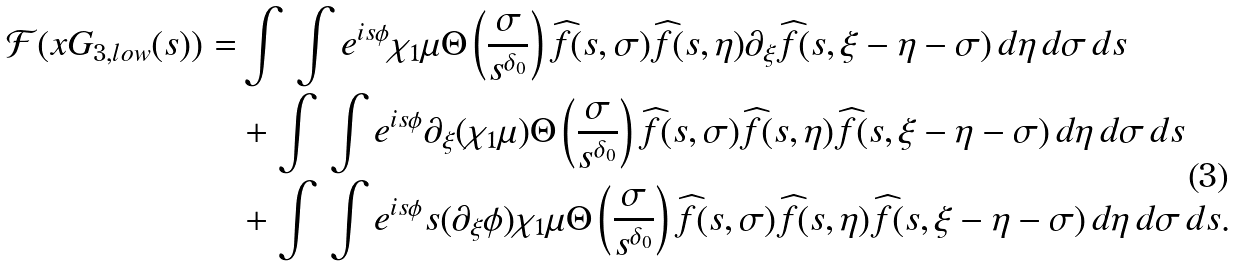Convert formula to latex. <formula><loc_0><loc_0><loc_500><loc_500>\mathcal { F } ( x G _ { 3 , l o w } ( s ) ) = & \int \, \int e ^ { i s \phi } \chi _ { 1 } \mu \Theta \left ( \frac { \sigma } { s ^ { \delta _ { 0 } } } \right ) \widehat { f } ( s , \sigma ) \widehat { f } ( s , \eta ) \partial _ { \xi } \widehat { f } ( s , \xi - \eta - \sigma ) \, d \eta \, d \sigma \, d s \\ & + \int \, \int e ^ { i s \phi } \partial _ { \xi } ( \chi _ { 1 } \mu ) \Theta \left ( \frac { \sigma } { s ^ { \delta _ { 0 } } } \right ) \widehat { f } ( s , \sigma ) \widehat { f } ( s , \eta ) \widehat { f } ( s , \xi - \eta - \sigma ) \, d \eta \, d \sigma \, d s \\ & + \int \, \int e ^ { i s \phi } s ( \partial _ { \xi } \phi ) \chi _ { 1 } \mu \Theta \left ( \frac { \sigma } { s ^ { \delta _ { 0 } } } \right ) \widehat { f } ( s , \sigma ) \widehat { f } ( s , \eta ) \widehat { f } ( s , \xi - \eta - \sigma ) \, d \eta \, d \sigma \, d s .</formula> 